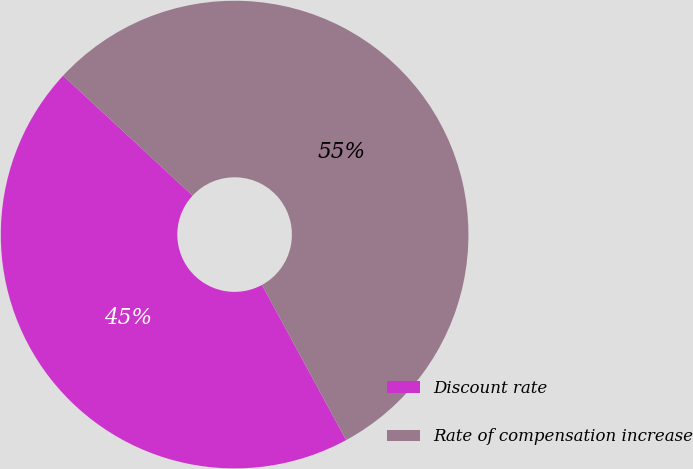Convert chart. <chart><loc_0><loc_0><loc_500><loc_500><pie_chart><fcel>Discount rate<fcel>Rate of compensation increase<nl><fcel>44.81%<fcel>55.19%<nl></chart> 